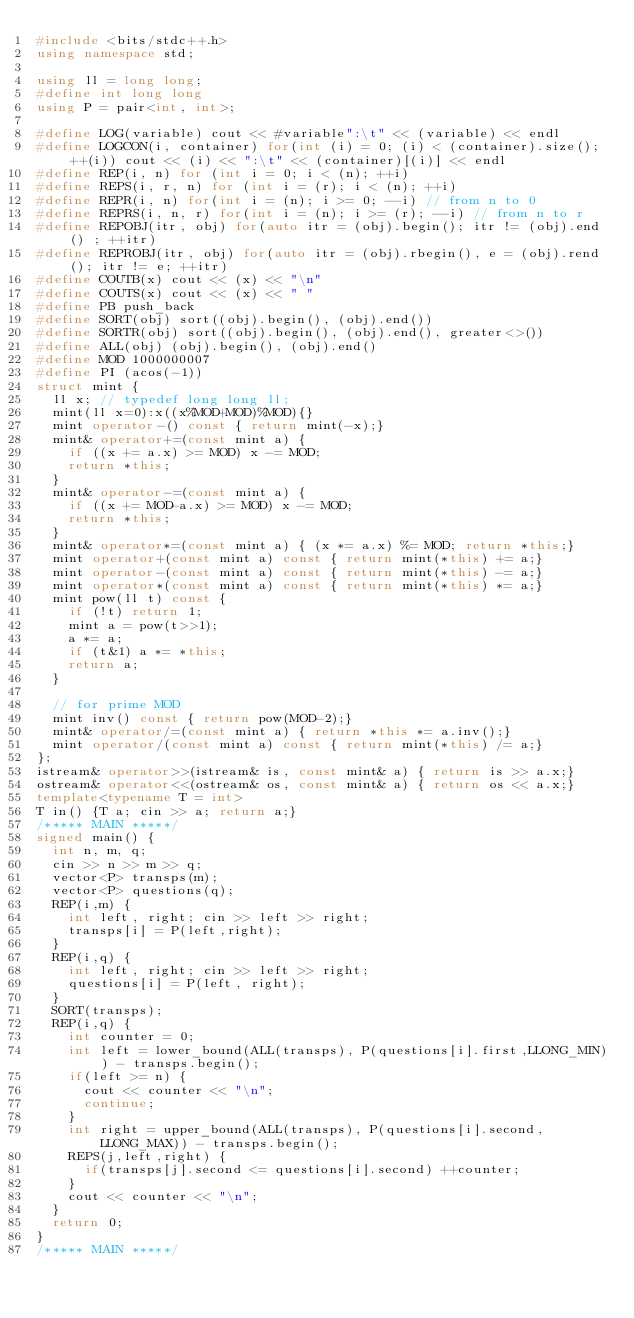Convert code to text. <code><loc_0><loc_0><loc_500><loc_500><_C++_>#include <bits/stdc++.h>
using namespace std;

using ll = long long;
#define int long long
using P = pair<int, int>;

#define LOG(variable) cout << #variable":\t" << (variable) << endl
#define LOGCON(i, container) for(int (i) = 0; (i) < (container).size(); ++(i)) cout << (i) << ":\t" << (container)[(i)] << endl
#define REP(i, n) for (int i = 0; i < (n); ++i)
#define REPS(i, r, n) for (int i = (r); i < (n); ++i)
#define REPR(i, n) for(int i = (n); i >= 0; --i) // from n to 0
#define REPRS(i, n, r) for(int i = (n); i >= (r); --i) // from n to r
#define REPOBJ(itr, obj) for(auto itr = (obj).begin(); itr != (obj).end() ; ++itr)
#define REPROBJ(itr, obj) for(auto itr = (obj).rbegin(), e = (obj).rend(); itr != e; ++itr)
#define COUTB(x) cout << (x) << "\n"
#define COUTS(x) cout << (x) << " "
#define PB push_back
#define SORT(obj) sort((obj).begin(), (obj).end())
#define SORTR(obj) sort((obj).begin(), (obj).end(), greater<>())
#define ALL(obj) (obj).begin(), (obj).end()
#define MOD 1000000007
#define PI (acos(-1))
struct mint {
  ll x; // typedef long long ll;
  mint(ll x=0):x((x%MOD+MOD)%MOD){}
  mint operator-() const { return mint(-x);}
  mint& operator+=(const mint a) {
    if ((x += a.x) >= MOD) x -= MOD;
    return *this;
  }
  mint& operator-=(const mint a) {
    if ((x += MOD-a.x) >= MOD) x -= MOD;
    return *this;
  }
  mint& operator*=(const mint a) { (x *= a.x) %= MOD; return *this;}
  mint operator+(const mint a) const { return mint(*this) += a;}
  mint operator-(const mint a) const { return mint(*this) -= a;}
  mint operator*(const mint a) const { return mint(*this) *= a;}
  mint pow(ll t) const {
    if (!t) return 1;
    mint a = pow(t>>1);
    a *= a;
    if (t&1) a *= *this;
    return a;
  }

  // for prime MOD
  mint inv() const { return pow(MOD-2);}
  mint& operator/=(const mint a) { return *this *= a.inv();}
  mint operator/(const mint a) const { return mint(*this) /= a;}
};
istream& operator>>(istream& is, const mint& a) { return is >> a.x;}
ostream& operator<<(ostream& os, const mint& a) { return os << a.x;}
template<typename T = int>
T in() {T a; cin >> a; return a;}
/***** MAIN *****/
signed main() {
  int n, m, q;
  cin >> n >> m >> q;
  vector<P> transps(m);
  vector<P> questions(q);
  REP(i,m) {
    int left, right; cin >> left >> right;
    transps[i] = P(left,right);
  }
  REP(i,q) {
    int left, right; cin >> left >> right;
    questions[i] = P(left, right);
  }
  SORT(transps);
  REP(i,q) {
    int counter = 0;
    int left = lower_bound(ALL(transps), P(questions[i].first,LLONG_MIN)) - transps.begin();
    if(left >= n) {
      cout << counter << "\n";
      continue;
    }
    int right = upper_bound(ALL(transps), P(questions[i].second,LLONG_MAX)) - transps.begin();
    REPS(j,left,right) {
      if(transps[j].second <= questions[i].second) ++counter;
    }
    cout << counter << "\n";
  }
  return 0;
}
/***** MAIN *****/
</code> 